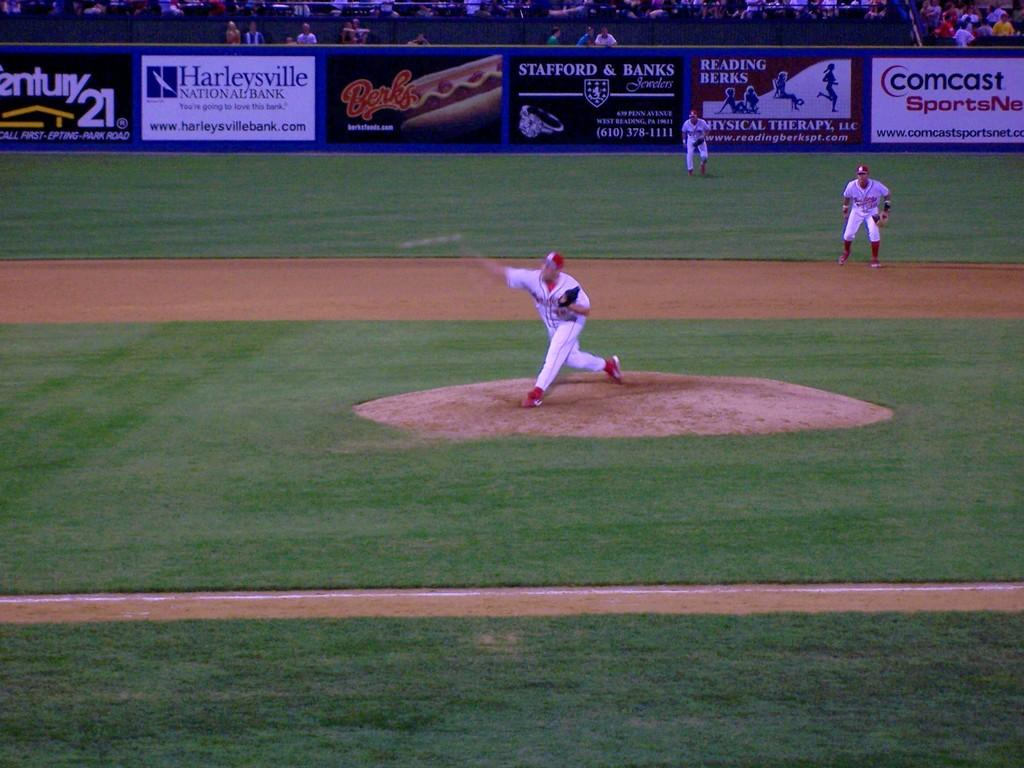What activity are the three people engaged in on the baseball ground? The three people are playing on the baseball ground. What structures can be seen on the baseball ground? There are posts on the baseball ground. Are there any spectators present in the image? Yes, there are people in the stands. What type of plants can be seen growing on the baseball field? There are no plants visible on the baseball field in the image. How does the fork contribute to the game being played on the baseball ground? There is no fork present in the image, so it cannot contribute to the game being played. 